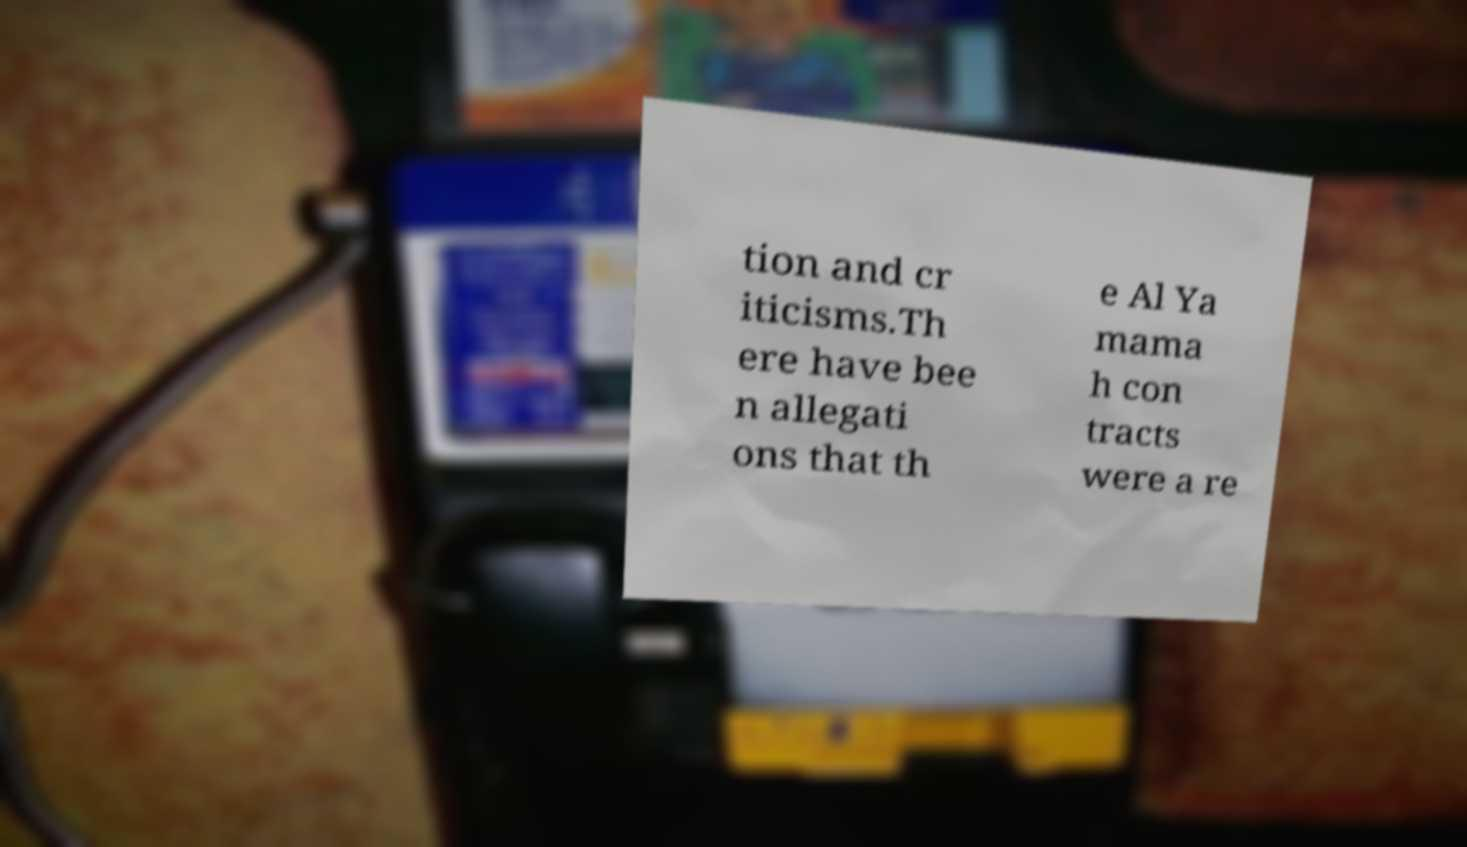What messages or text are displayed in this image? I need them in a readable, typed format. tion and cr iticisms.Th ere have bee n allegati ons that th e Al Ya mama h con tracts were a re 